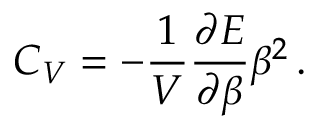Convert formula to latex. <formula><loc_0><loc_0><loc_500><loc_500>C _ { V } = - \frac { 1 } { V } \frac { \partial E } { \partial \beta } \beta ^ { 2 } \, .</formula> 